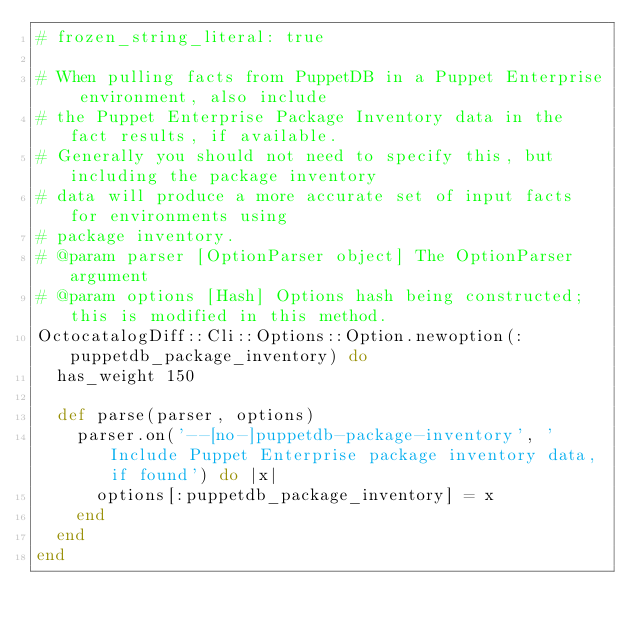<code> <loc_0><loc_0><loc_500><loc_500><_Ruby_># frozen_string_literal: true

# When pulling facts from PuppetDB in a Puppet Enterprise environment, also include
# the Puppet Enterprise Package Inventory data in the fact results, if available.
# Generally you should not need to specify this, but including the package inventory
# data will produce a more accurate set of input facts for environments using
# package inventory.
# @param parser [OptionParser object] The OptionParser argument
# @param options [Hash] Options hash being constructed; this is modified in this method.
OctocatalogDiff::Cli::Options::Option.newoption(:puppetdb_package_inventory) do
  has_weight 150

  def parse(parser, options)
    parser.on('--[no-]puppetdb-package-inventory', 'Include Puppet Enterprise package inventory data, if found') do |x|
      options[:puppetdb_package_inventory] = x
    end
  end
end
</code> 